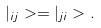Convert formula to latex. <formula><loc_0><loc_0><loc_500><loc_500>| _ { i j } > = | _ { j i } > .</formula> 